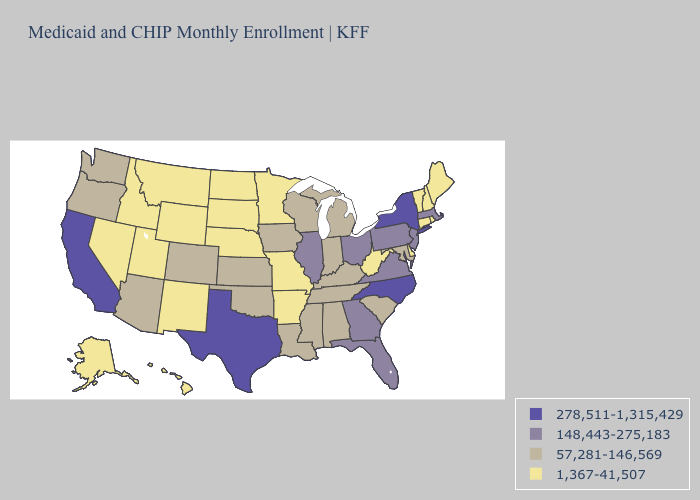What is the lowest value in the West?
Write a very short answer. 1,367-41,507. Does Vermont have the lowest value in the USA?
Write a very short answer. Yes. Among the states that border Maine , which have the highest value?
Quick response, please. New Hampshire. Does Virginia have the lowest value in the USA?
Give a very brief answer. No. Among the states that border West Virginia , does Maryland have the highest value?
Answer briefly. No. What is the value of Kentucky?
Concise answer only. 57,281-146,569. Which states have the lowest value in the MidWest?
Give a very brief answer. Minnesota, Missouri, Nebraska, North Dakota, South Dakota. Name the states that have a value in the range 278,511-1,315,429?
Give a very brief answer. California, New York, North Carolina, Texas. Is the legend a continuous bar?
Quick response, please. No. Does Indiana have the highest value in the USA?
Answer briefly. No. Name the states that have a value in the range 148,443-275,183?
Concise answer only. Florida, Georgia, Illinois, Massachusetts, New Jersey, Ohio, Pennsylvania, Virginia. Among the states that border Delaware , does New Jersey have the highest value?
Concise answer only. Yes. What is the value of Michigan?
Concise answer only. 57,281-146,569. Is the legend a continuous bar?
Keep it brief. No. Among the states that border South Dakota , does Montana have the highest value?
Write a very short answer. No. 